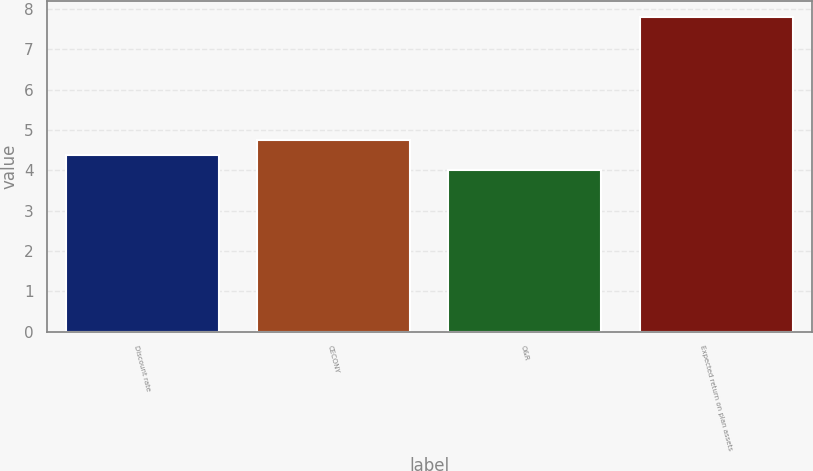Convert chart to OTSL. <chart><loc_0><loc_0><loc_500><loc_500><bar_chart><fcel>Discount rate<fcel>CECONY<fcel>O&R<fcel>Expected return on plan assets<nl><fcel>4.38<fcel>4.76<fcel>4<fcel>7.8<nl></chart> 